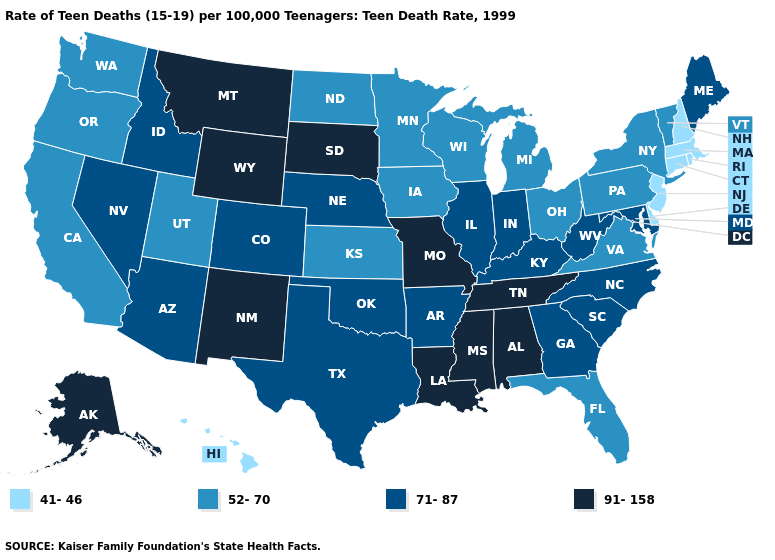What is the highest value in the USA?
Concise answer only. 91-158. What is the value of Connecticut?
Answer briefly. 41-46. Name the states that have a value in the range 71-87?
Answer briefly. Arizona, Arkansas, Colorado, Georgia, Idaho, Illinois, Indiana, Kentucky, Maine, Maryland, Nebraska, Nevada, North Carolina, Oklahoma, South Carolina, Texas, West Virginia. Does Washington have the highest value in the USA?
Write a very short answer. No. Does the first symbol in the legend represent the smallest category?
Short answer required. Yes. What is the value of Georgia?
Keep it brief. 71-87. Which states have the lowest value in the South?
Write a very short answer. Delaware. Does Tennessee have the highest value in the South?
Write a very short answer. Yes. What is the value of Ohio?
Short answer required. 52-70. Name the states that have a value in the range 41-46?
Give a very brief answer. Connecticut, Delaware, Hawaii, Massachusetts, New Hampshire, New Jersey, Rhode Island. Does South Dakota have the same value as South Carolina?
Short answer required. No. Which states have the lowest value in the West?
Answer briefly. Hawaii. What is the lowest value in states that border New Mexico?
Give a very brief answer. 52-70. What is the value of Texas?
Short answer required. 71-87. Does Connecticut have the same value as Montana?
Answer briefly. No. 